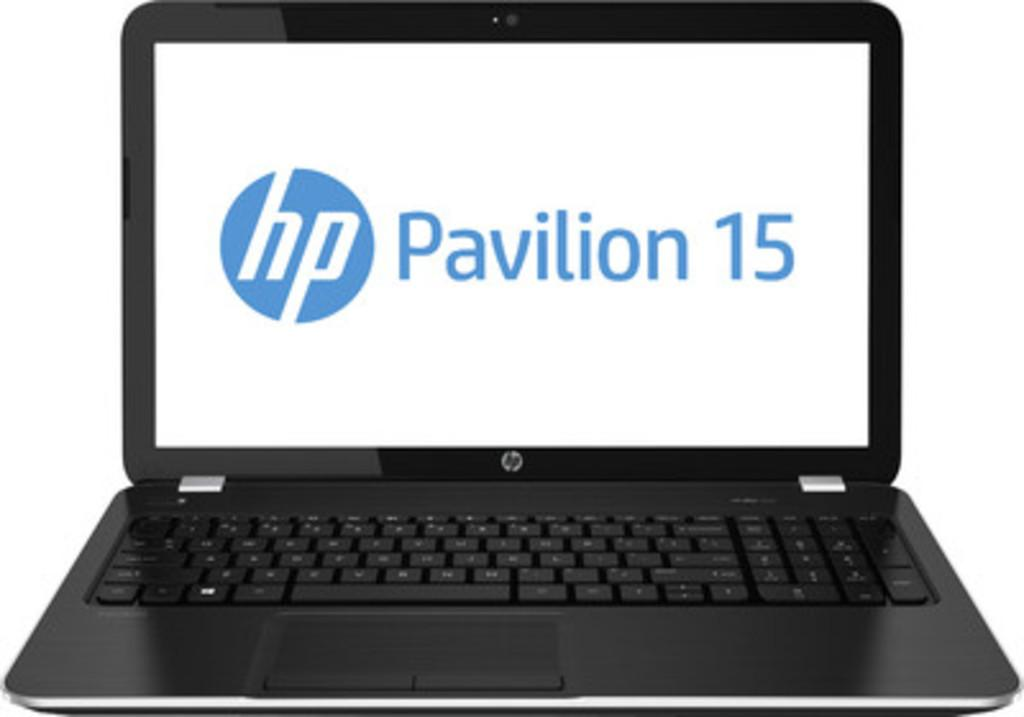<image>
Describe the image concisely. Black HP laptop that says Pavilion 15 on the screen. 